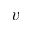<formula> <loc_0><loc_0><loc_500><loc_500>v</formula> 